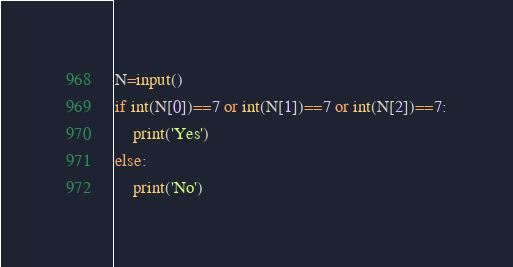<code> <loc_0><loc_0><loc_500><loc_500><_Python_>N=input()
if int(N[0])==7 or int(N[1])==7 or int(N[2])==7:
	print('Yes')
else:
	print('No')</code> 